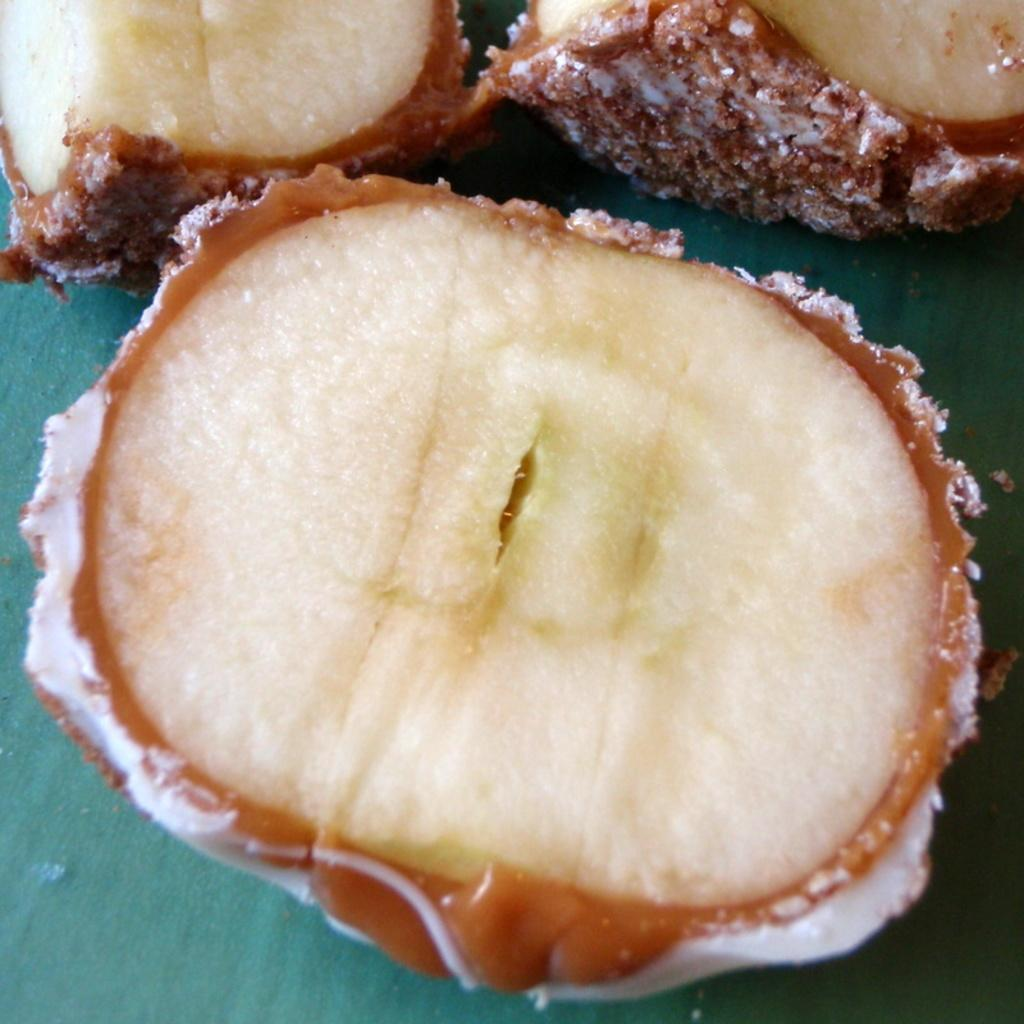What is the main subject of the image? The main subject of the image is food. On what surface is the food placed? The food is placed on a green surface. What colors can be observed in the food? The food has brown and cream colors. How many roses are present in the image? There are no roses visible in the image; it features food placed on a green surface. What type of seat can be seen in the image? There is no seat present in the image; it only shows food on a green surface. 